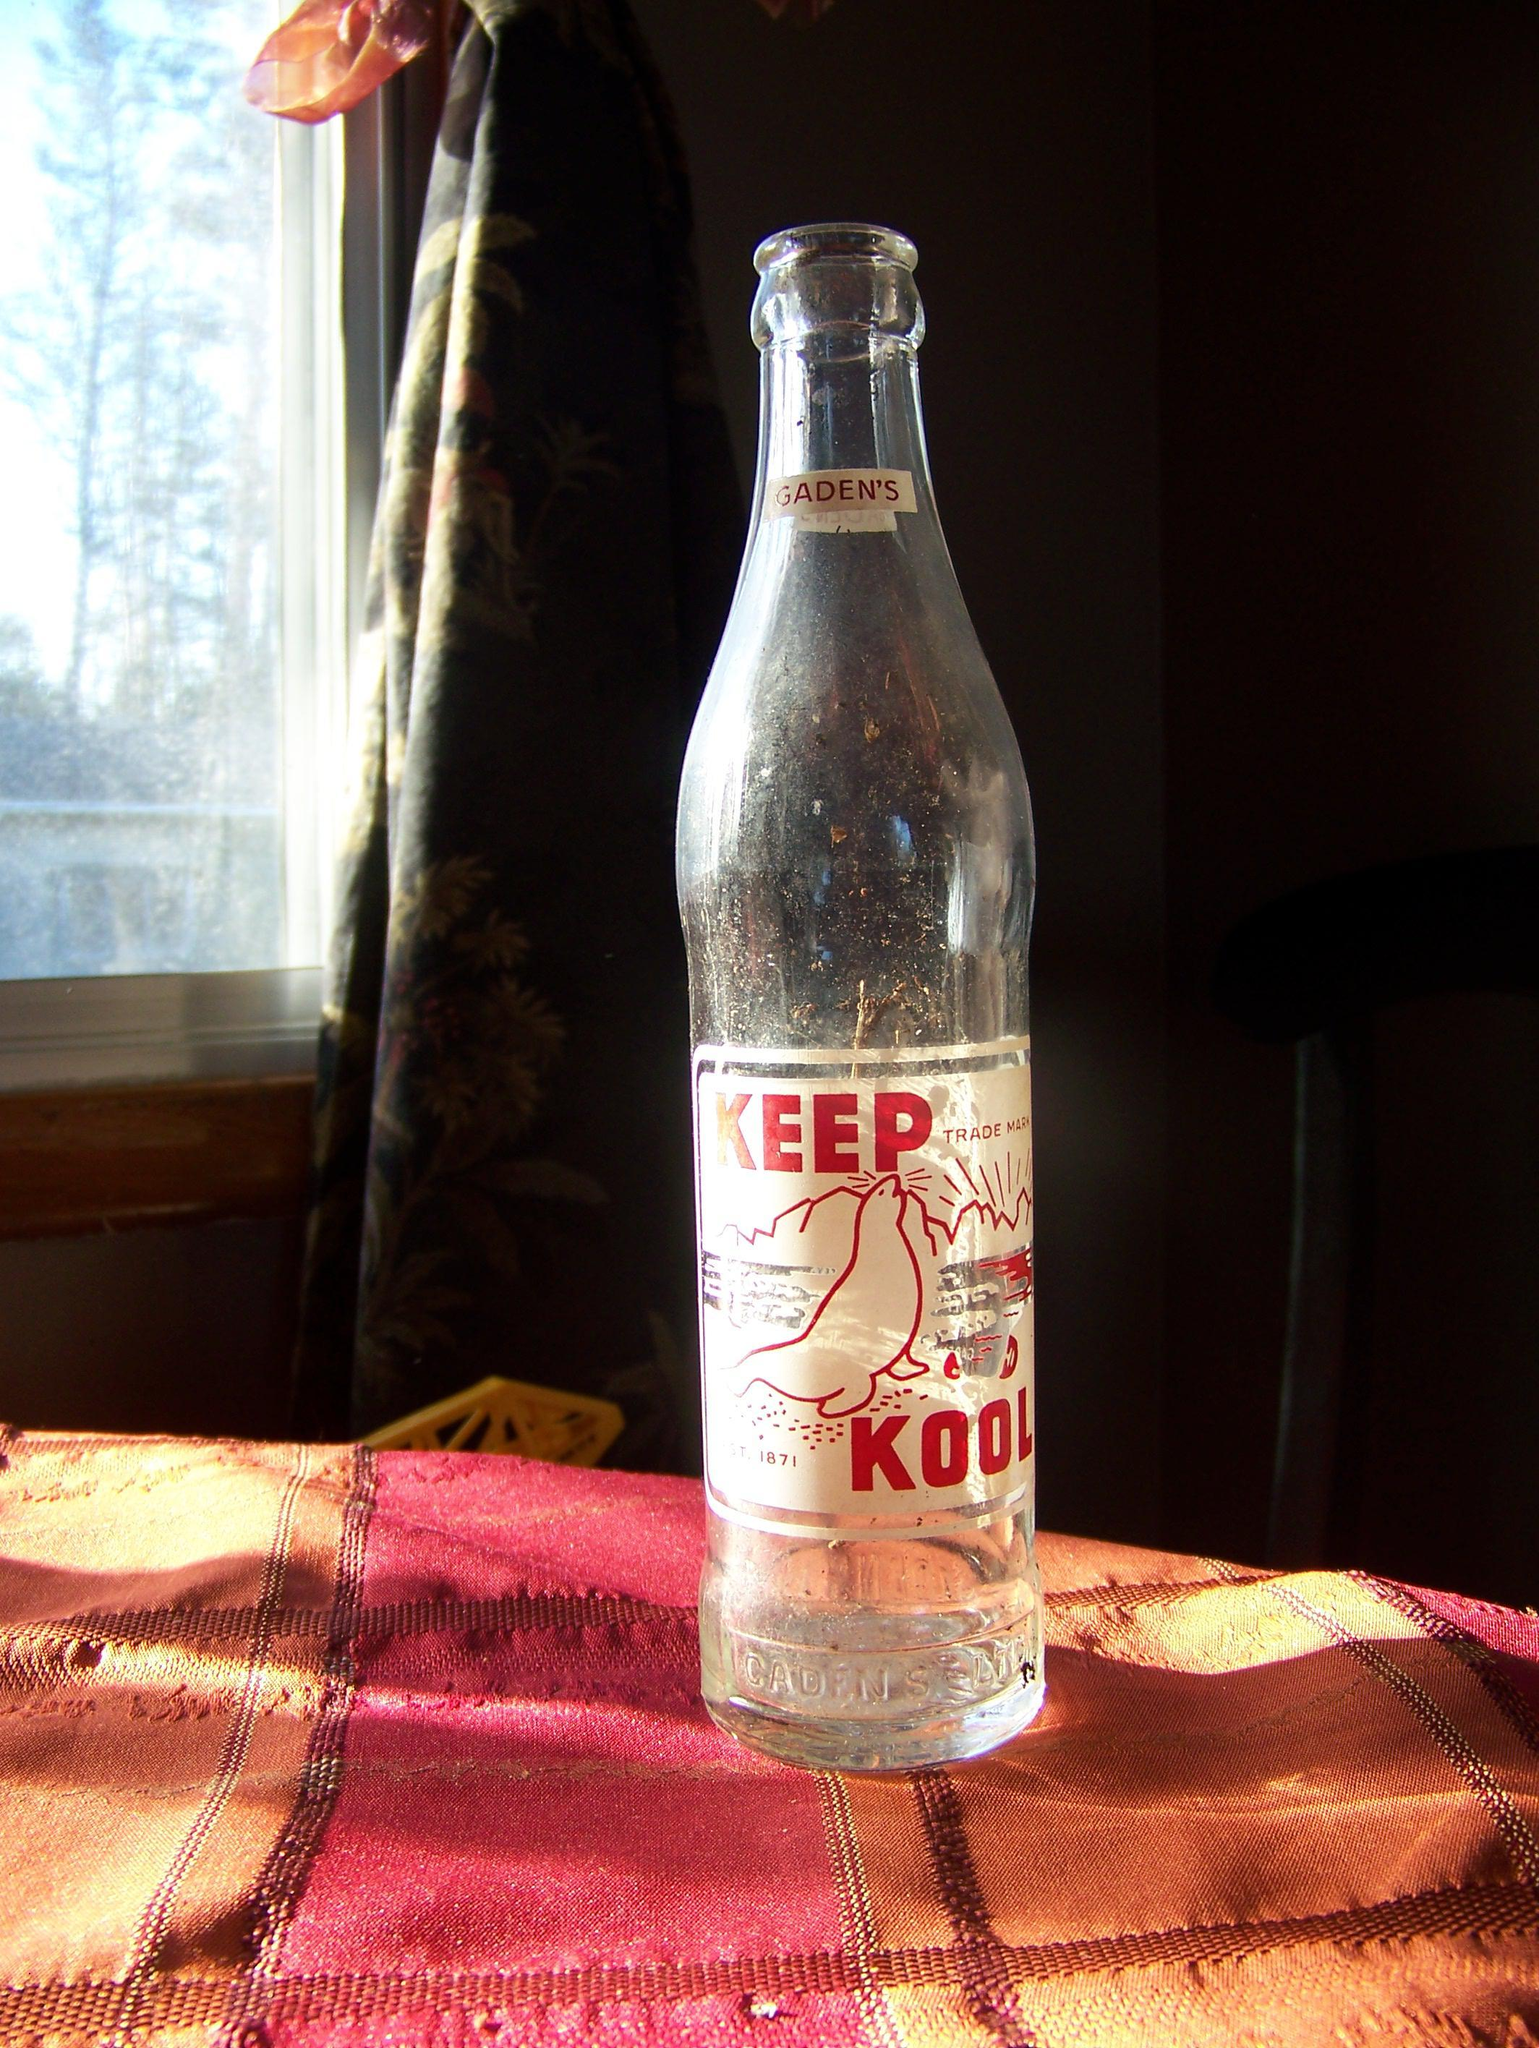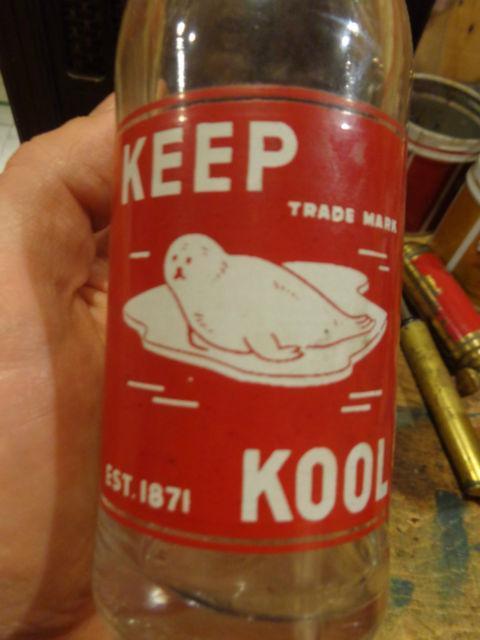The first image is the image on the left, the second image is the image on the right. Given the left and right images, does the statement "One image shows a group of overlapping old-fashioned glass soda bottles with a variety of labels, shapes and sizes." hold true? Answer yes or no. No. The first image is the image on the left, the second image is the image on the right. Evaluate the accuracy of this statement regarding the images: "The bottles in one of the images have been painted.". Is it true? Answer yes or no. No. 